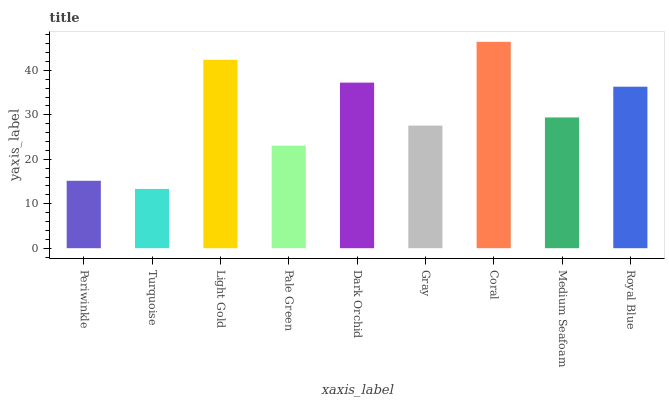Is Light Gold the minimum?
Answer yes or no. No. Is Light Gold the maximum?
Answer yes or no. No. Is Light Gold greater than Turquoise?
Answer yes or no. Yes. Is Turquoise less than Light Gold?
Answer yes or no. Yes. Is Turquoise greater than Light Gold?
Answer yes or no. No. Is Light Gold less than Turquoise?
Answer yes or no. No. Is Medium Seafoam the high median?
Answer yes or no. Yes. Is Medium Seafoam the low median?
Answer yes or no. Yes. Is Royal Blue the high median?
Answer yes or no. No. Is Light Gold the low median?
Answer yes or no. No. 